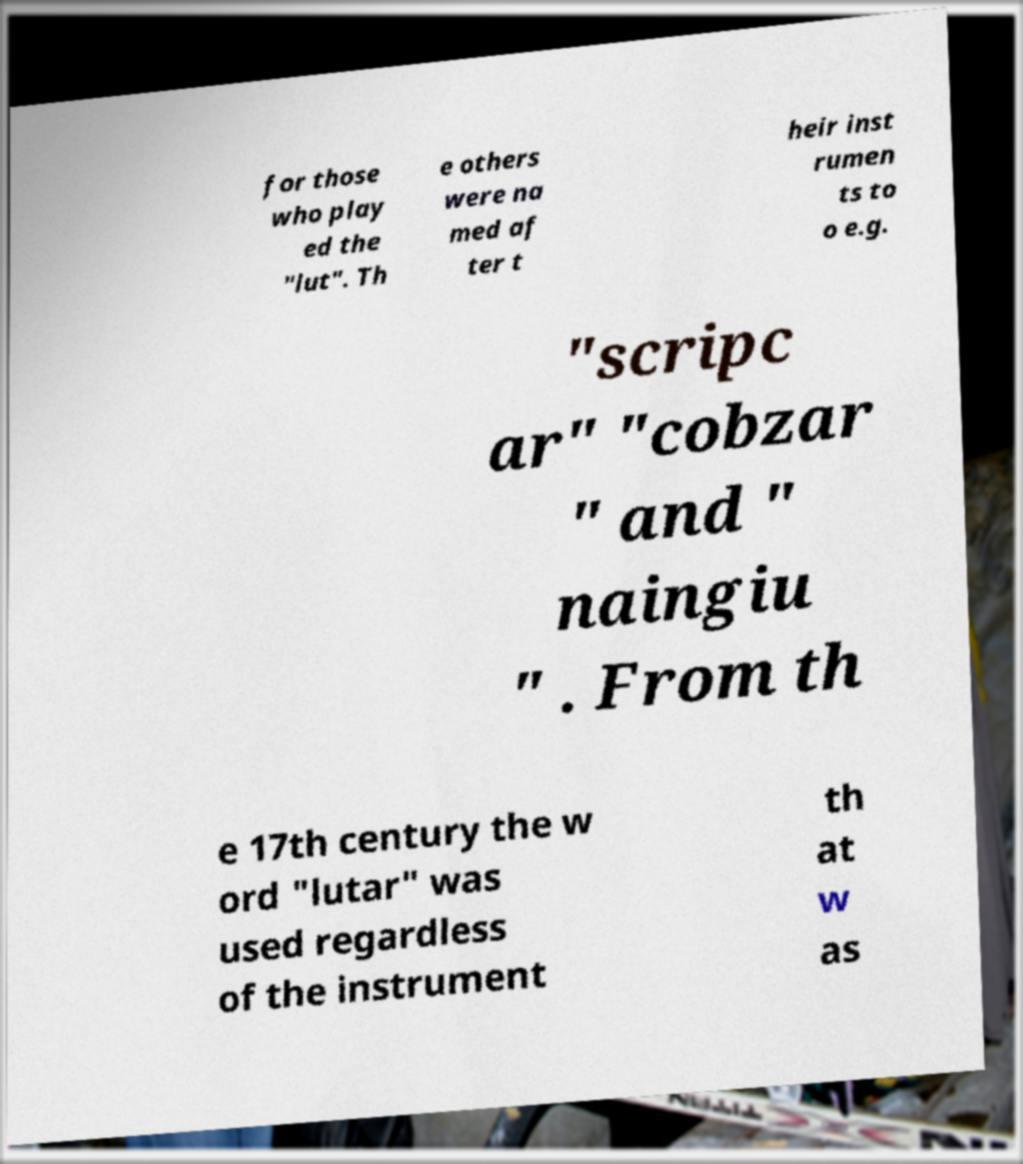I need the written content from this picture converted into text. Can you do that? for those who play ed the "lut". Th e others were na med af ter t heir inst rumen ts to o e.g. "scripc ar" "cobzar " and " naingiu " . From th e 17th century the w ord "lutar" was used regardless of the instrument th at w as 